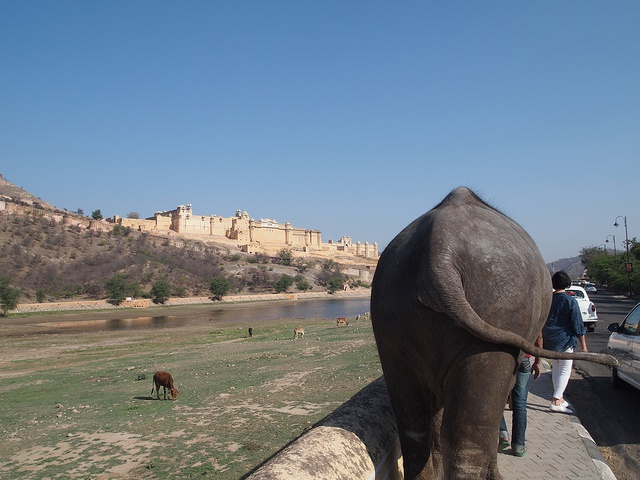Describe the objects in this image and their specific colors. I can see elephant in gray and black tones, people in gray, black, lightgray, and navy tones, people in gray, black, darkgray, and blue tones, car in gray and black tones, and car in gray, lightgray, black, and darkgray tones in this image. 